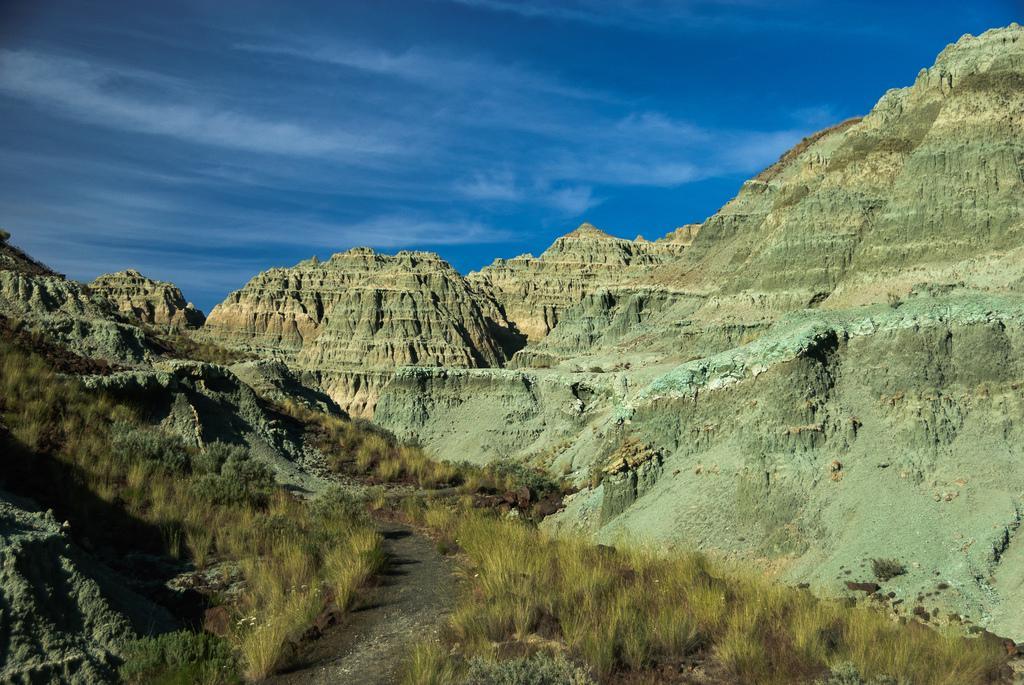Could you give a brief overview of what you see in this image? There is a small road. There are grasses on the ground. In the back there are hills. In the background there is sky. 